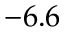Convert formula to latex. <formula><loc_0><loc_0><loc_500><loc_500>- 6 . 6</formula> 